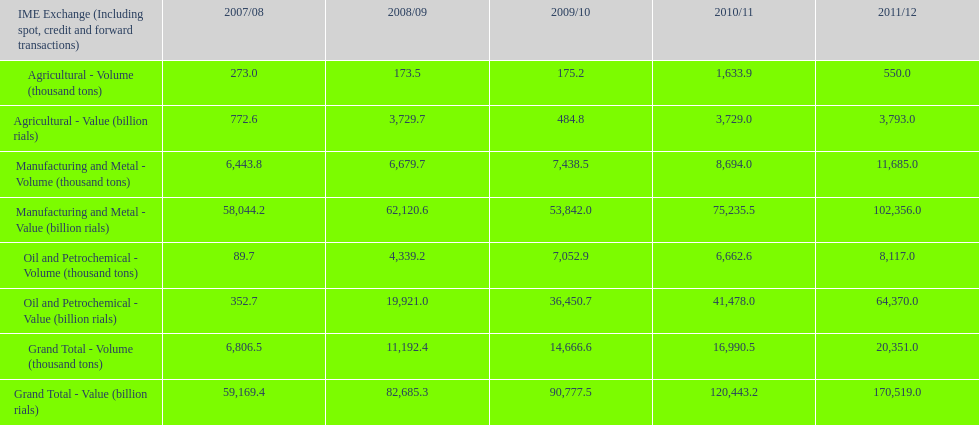What is the total agricultural value in 2008/09? 3,729.7. 